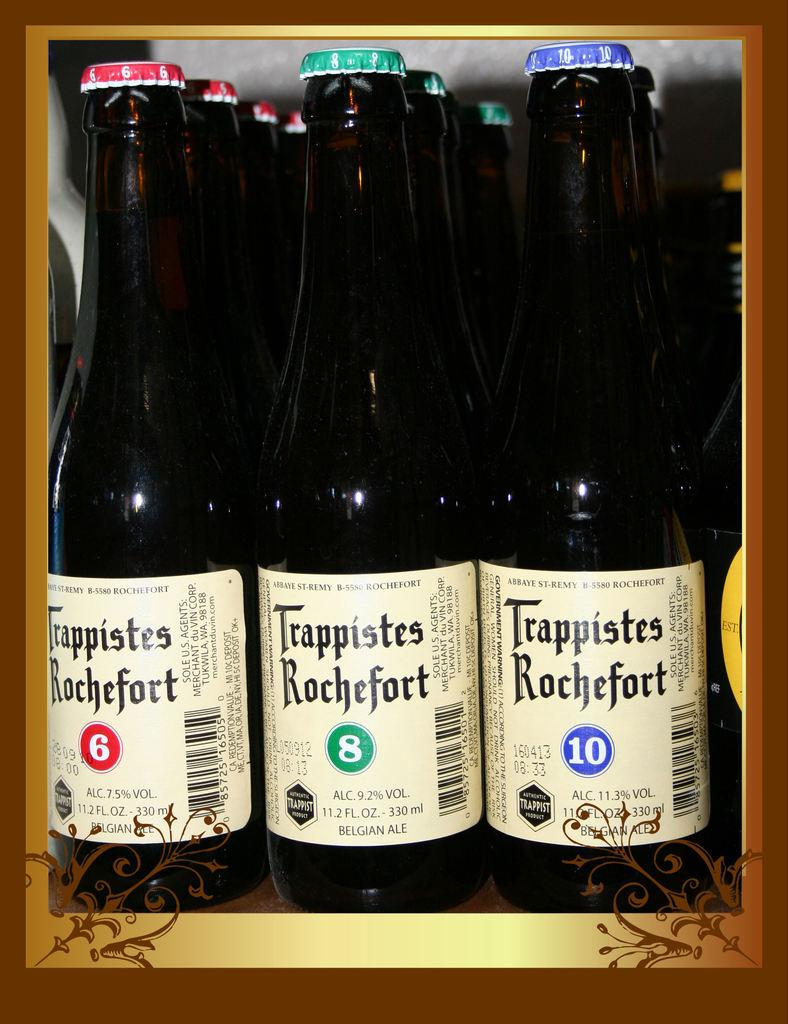What can be seen on the tops of the bottles in the image? There are bottles with different color caps in the image. What information is provided on the bottles themselves? The bottles have labels with text and bar codes. What type of beam is holding up the bottles in the image? There is no beam present in the image; the bottles are likely standing on a flat surface. 